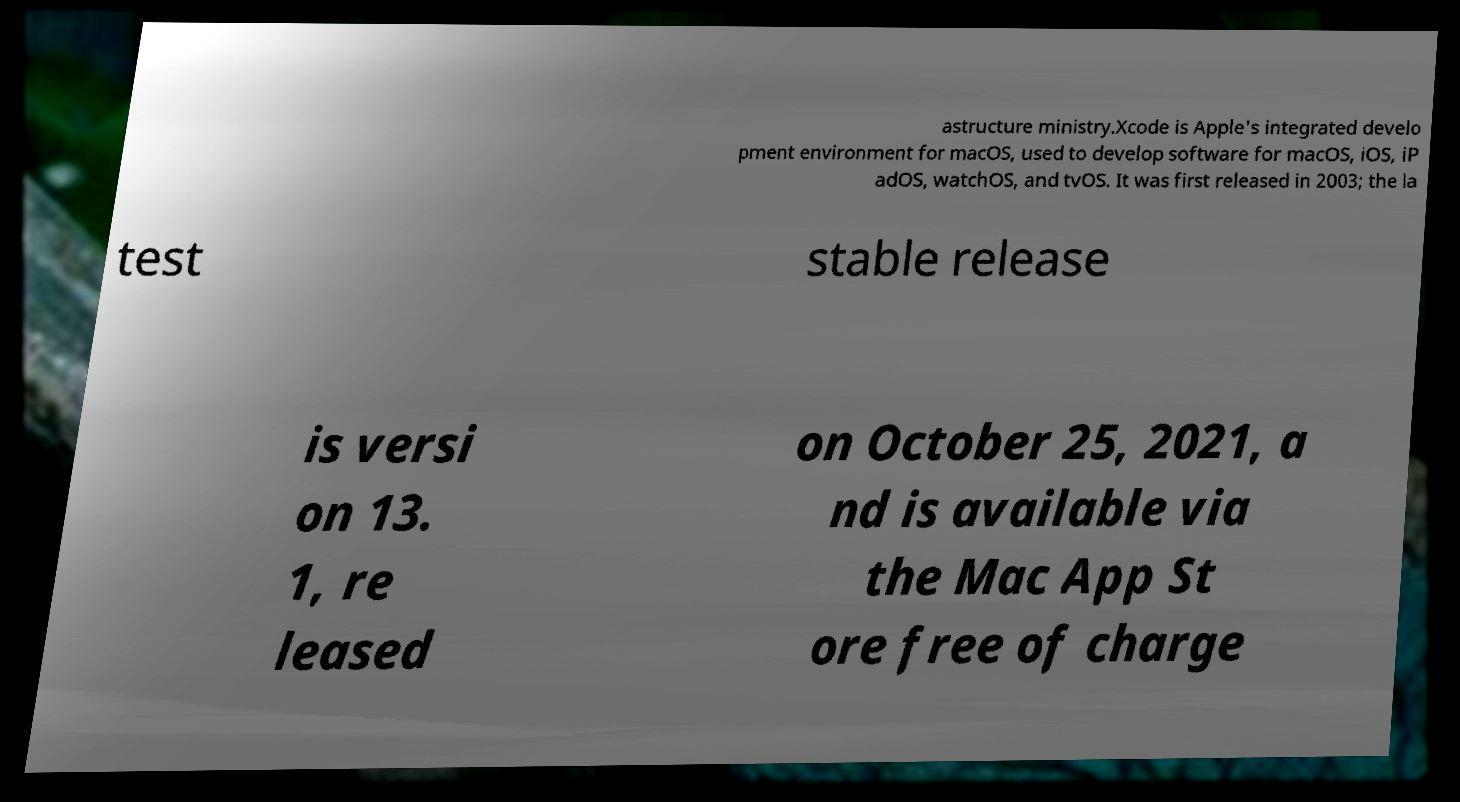For documentation purposes, I need the text within this image transcribed. Could you provide that? astructure ministry.Xcode is Apple's integrated develo pment environment for macOS, used to develop software for macOS, iOS, iP adOS, watchOS, and tvOS. It was first released in 2003; the la test stable release is versi on 13. 1, re leased on October 25, 2021, a nd is available via the Mac App St ore free of charge 